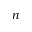Convert formula to latex. <formula><loc_0><loc_0><loc_500><loc_500>n</formula> 